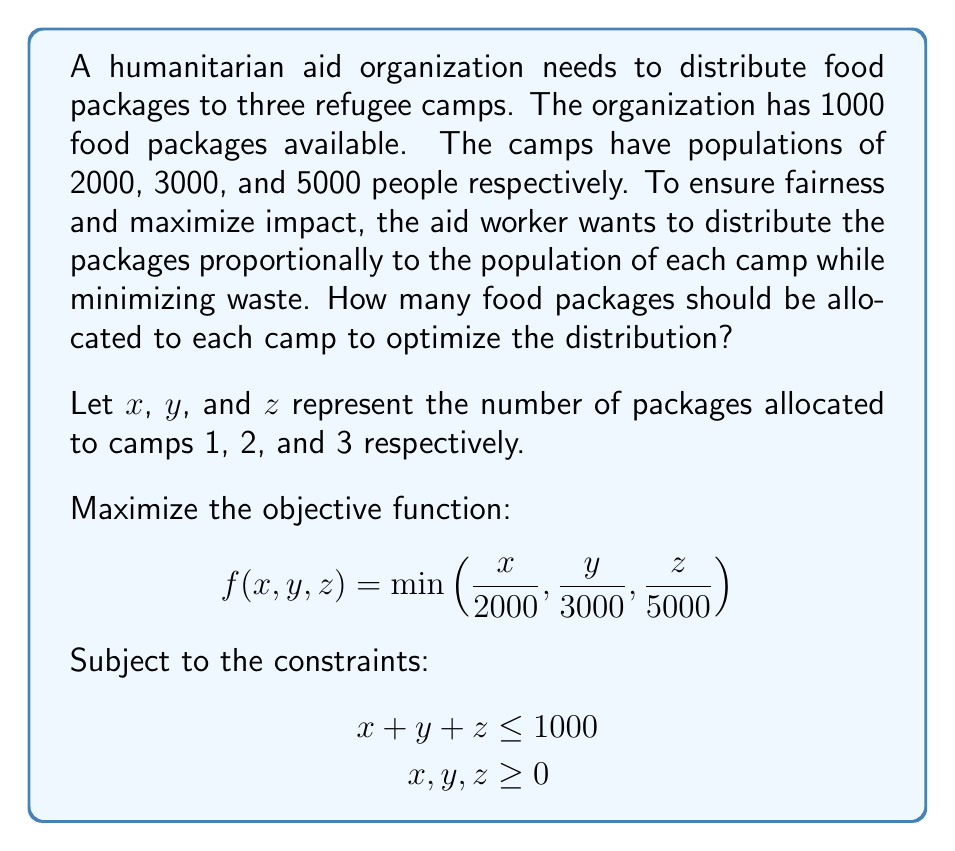Help me with this question. To solve this optimization problem, we'll use the method of equal proportions:

1) We want to maximize the minimum ratio of packages to population across all camps. This occurs when all ratios are equal:

   $$\frac{x}{2000} = \frac{y}{3000} = \frac{z}{5000} = k$$

2) Express $x$, $y$, and $z$ in terms of $k$:
   $$x = 2000k, \quad y = 3000k, \quad z = 5000k$$

3) Substitute these into the constraint equation:
   $$x + y + z \leq 1000$$
   $$2000k + 3000k + 5000k \leq 1000$$
   $$10000k \leq 1000$$
   $$k \leq 0.1$$

4) To maximize $k$ while satisfying the constraint, we set $k = 0.1$

5) Now we can calculate $x$, $y$, and $z$:
   $$x = 2000 * 0.1 = 200$$
   $$y = 3000 * 0.1 = 300$$
   $$z = 5000 * 0.1 = 500$$

6) Verify that the sum equals 1000:
   $$200 + 300 + 500 = 1000$$

This allocation ensures that each person in each camp has an equal chance of receiving a food package, optimizing fairness in the distribution.
Answer: Camp 1: 200 packages
Camp 2: 300 packages
Camp 3: 500 packages 